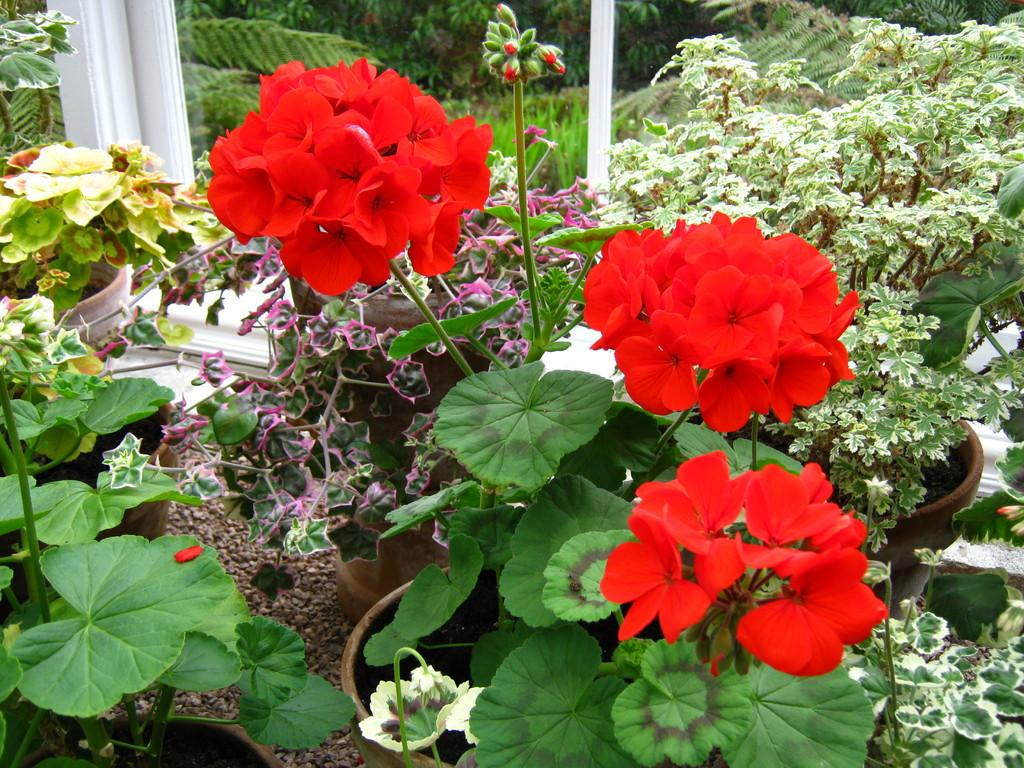What type of location is shown in the image? The image depicts a garden. What can be found in the garden? There are beautiful flower plants in the garden. What is located behind the flower plants? There are trees behind the flower plants. What type of ground cover is present in the garden? There is grass in the garden. What type of bubble can be seen floating in the garden? There is no bubble present in the image; it depicts a garden with flower plants, trees, and grass. 